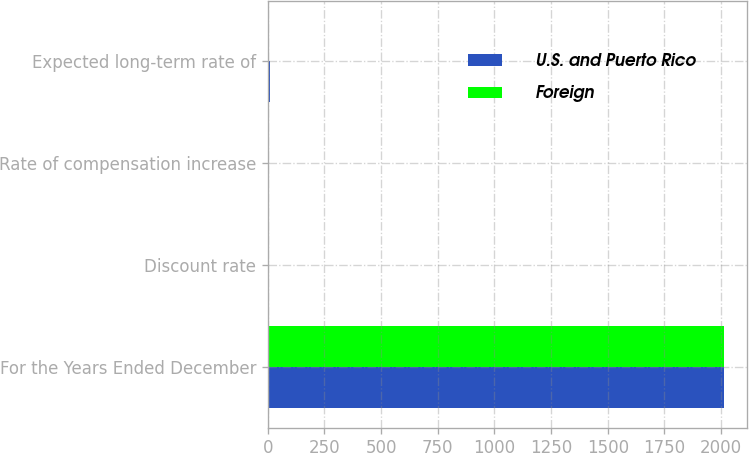Convert chart. <chart><loc_0><loc_0><loc_500><loc_500><stacked_bar_chart><ecel><fcel>For the Years Ended December<fcel>Discount rate<fcel>Rate of compensation increase<fcel>Expected long-term rate of<nl><fcel>U.S. and Puerto Rico<fcel>2014<fcel>4.98<fcel>3.29<fcel>7.75<nl><fcel>Foreign<fcel>2014<fcel>2.46<fcel>1.48<fcel>2.88<nl></chart> 